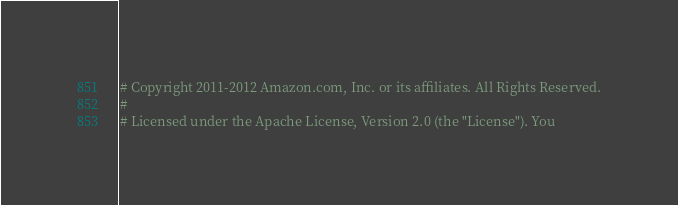Convert code to text. <code><loc_0><loc_0><loc_500><loc_500><_Ruby_># Copyright 2011-2012 Amazon.com, Inc. or its affiliates. All Rights Reserved.
#
# Licensed under the Apache License, Version 2.0 (the "License"). You</code> 